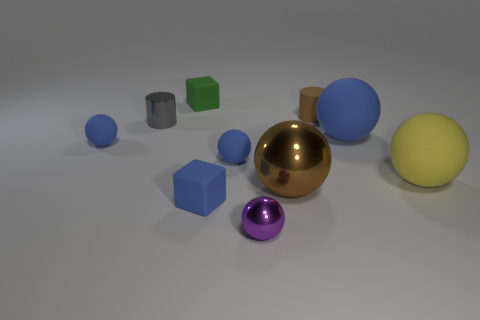How many blue spheres must be subtracted to get 1 blue spheres? 2 Subtract all large blue matte balls. How many balls are left? 5 Subtract all yellow balls. How many balls are left? 5 Subtract all blocks. How many objects are left? 8 Subtract 2 blocks. How many blocks are left? 0 Subtract all gray cubes. How many blue balls are left? 3 Subtract all tiny purple balls. Subtract all tiny green matte cylinders. How many objects are left? 9 Add 3 small purple objects. How many small purple objects are left? 4 Add 7 yellow matte balls. How many yellow matte balls exist? 8 Subtract 0 gray blocks. How many objects are left? 10 